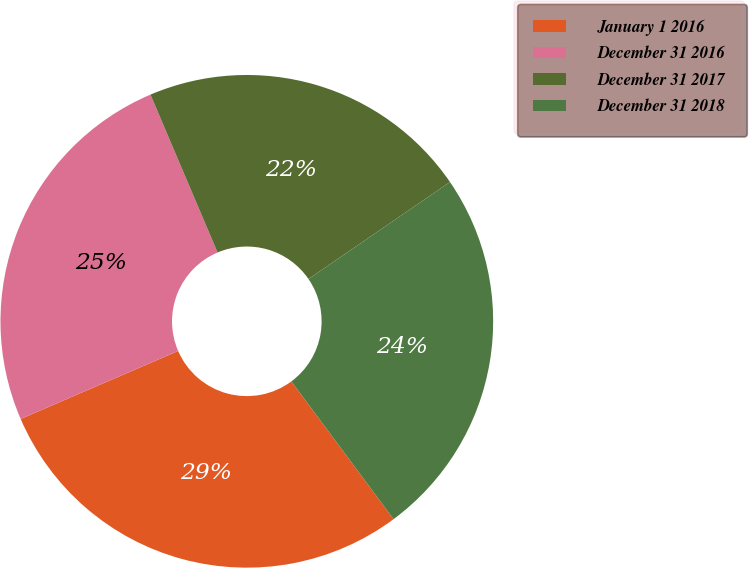Convert chart. <chart><loc_0><loc_0><loc_500><loc_500><pie_chart><fcel>January 1 2016<fcel>December 31 2016<fcel>December 31 2017<fcel>December 31 2018<nl><fcel>28.67%<fcel>25.09%<fcel>21.83%<fcel>24.41%<nl></chart> 